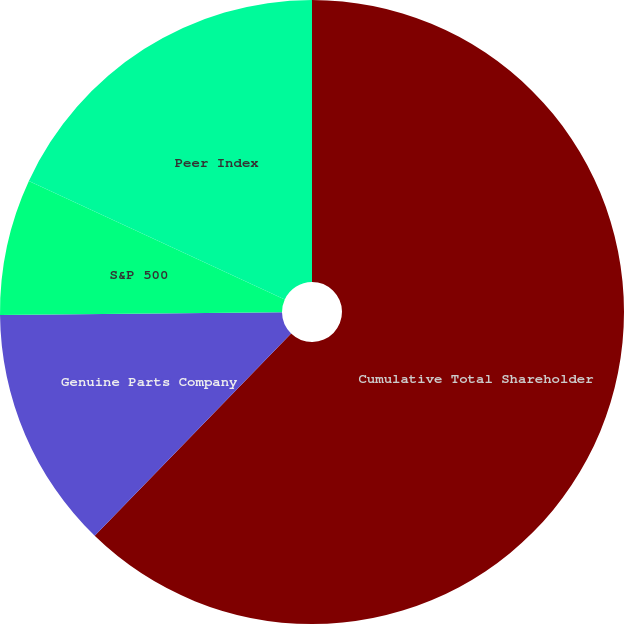Convert chart. <chart><loc_0><loc_0><loc_500><loc_500><pie_chart><fcel>Cumulative Total Shareholder<fcel>Genuine Parts Company<fcel>S&P 500<fcel>Peer Index<nl><fcel>62.27%<fcel>12.58%<fcel>7.06%<fcel>18.1%<nl></chart> 